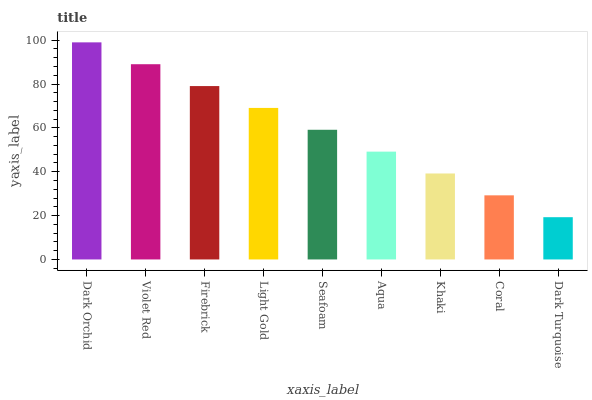Is Violet Red the minimum?
Answer yes or no. No. Is Violet Red the maximum?
Answer yes or no. No. Is Dark Orchid greater than Violet Red?
Answer yes or no. Yes. Is Violet Red less than Dark Orchid?
Answer yes or no. Yes. Is Violet Red greater than Dark Orchid?
Answer yes or no. No. Is Dark Orchid less than Violet Red?
Answer yes or no. No. Is Seafoam the high median?
Answer yes or no. Yes. Is Seafoam the low median?
Answer yes or no. Yes. Is Dark Turquoise the high median?
Answer yes or no. No. Is Light Gold the low median?
Answer yes or no. No. 